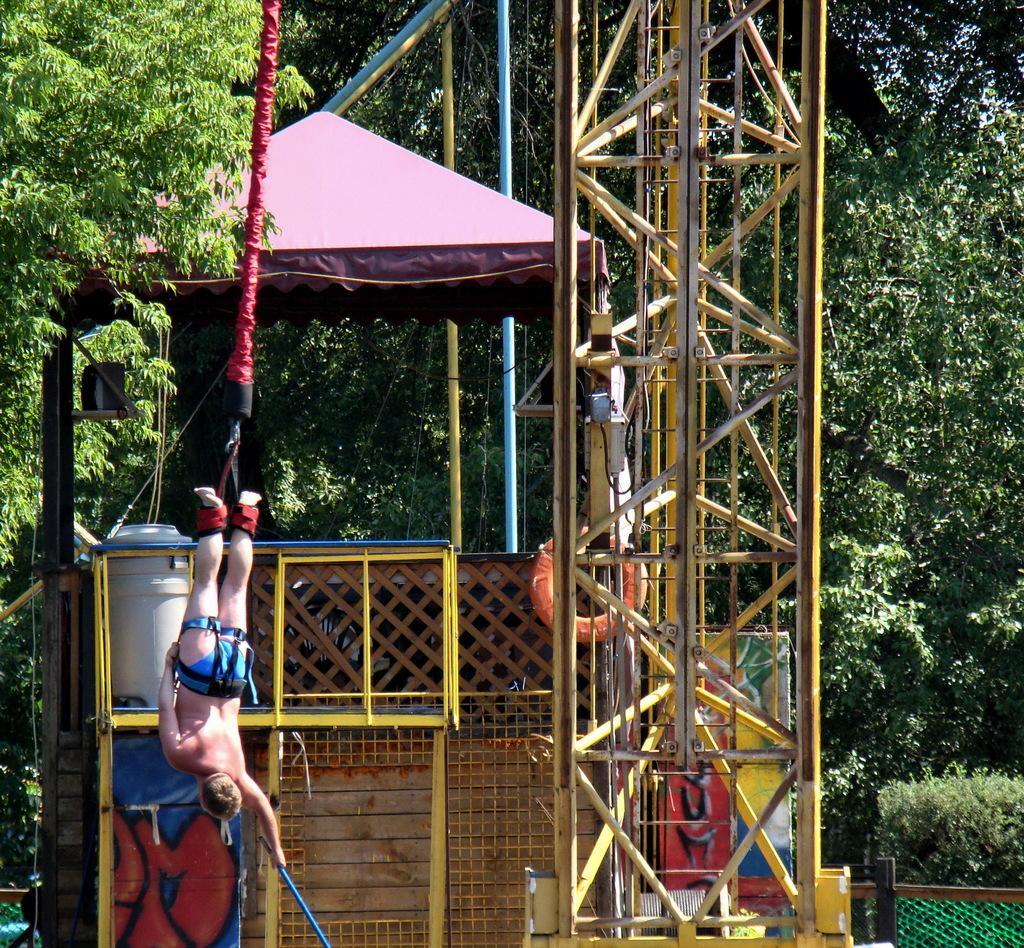Could you give a brief overview of what you see in this image? In this image we can see tower, tube, rope, person, tree, tent and fencing. 